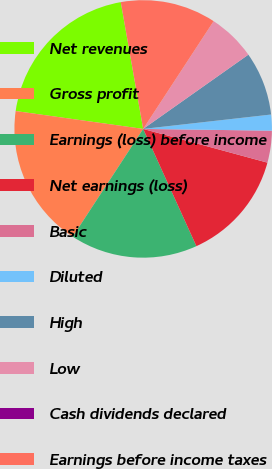<chart> <loc_0><loc_0><loc_500><loc_500><pie_chart><fcel>Net revenues<fcel>Gross profit<fcel>Earnings (loss) before income<fcel>Net earnings (loss)<fcel>Basic<fcel>Diluted<fcel>High<fcel>Low<fcel>Cash dividends declared<fcel>Earnings before income taxes<nl><fcel>20.0%<fcel>18.0%<fcel>16.0%<fcel>14.0%<fcel>4.0%<fcel>2.0%<fcel>8.0%<fcel>6.0%<fcel>0.0%<fcel>12.0%<nl></chart> 